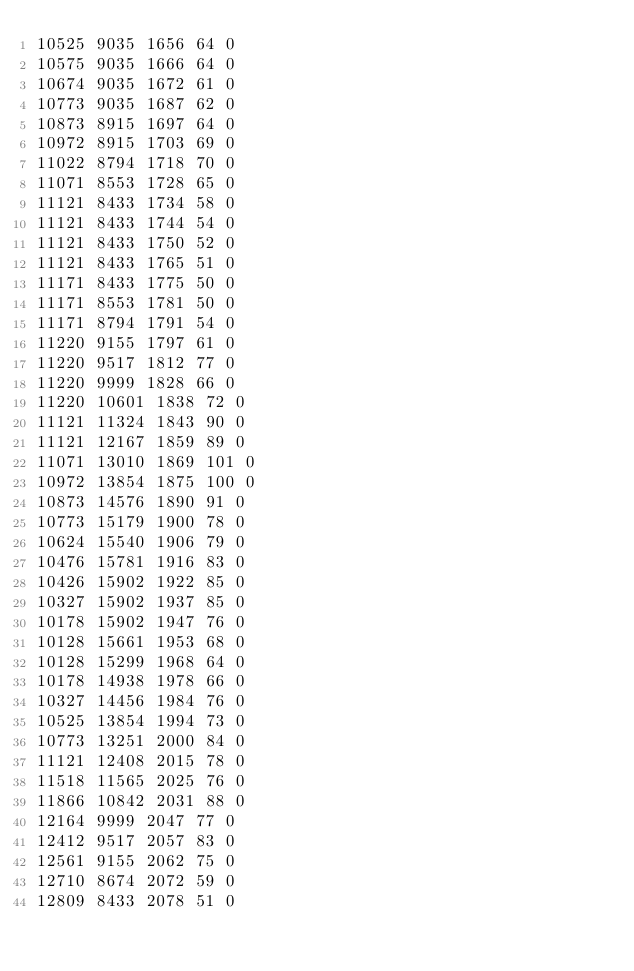<code> <loc_0><loc_0><loc_500><loc_500><_SML_>10525 9035 1656 64 0
10575 9035 1666 64 0
10674 9035 1672 61 0
10773 9035 1687 62 0
10873 8915 1697 64 0
10972 8915 1703 69 0
11022 8794 1718 70 0
11071 8553 1728 65 0
11121 8433 1734 58 0
11121 8433 1744 54 0
11121 8433 1750 52 0
11121 8433 1765 51 0
11171 8433 1775 50 0
11171 8553 1781 50 0
11171 8794 1791 54 0
11220 9155 1797 61 0
11220 9517 1812 77 0
11220 9999 1828 66 0
11220 10601 1838 72 0
11121 11324 1843 90 0
11121 12167 1859 89 0
11071 13010 1869 101 0
10972 13854 1875 100 0
10873 14576 1890 91 0
10773 15179 1900 78 0
10624 15540 1906 79 0
10476 15781 1916 83 0
10426 15902 1922 85 0
10327 15902 1937 85 0
10178 15902 1947 76 0
10128 15661 1953 68 0
10128 15299 1968 64 0
10178 14938 1978 66 0
10327 14456 1984 76 0
10525 13854 1994 73 0
10773 13251 2000 84 0
11121 12408 2015 78 0
11518 11565 2025 76 0
11866 10842 2031 88 0
12164 9999 2047 77 0
12412 9517 2057 83 0
12561 9155 2062 75 0
12710 8674 2072 59 0
12809 8433 2078 51 0</code> 